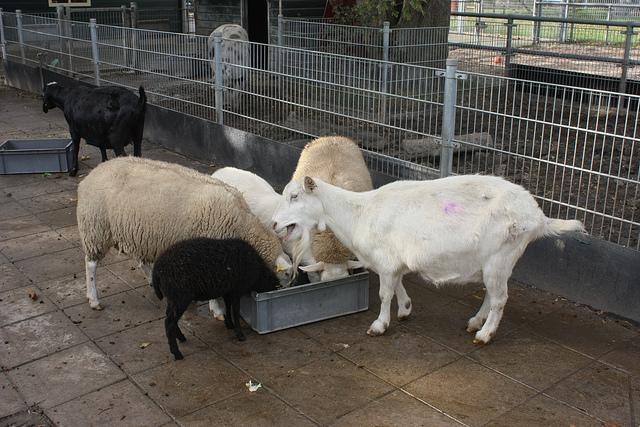Why are the animals crowded around the bucket?

Choices:
A) to graze
B) to bathe
C) to rest
D) to eat to eat 